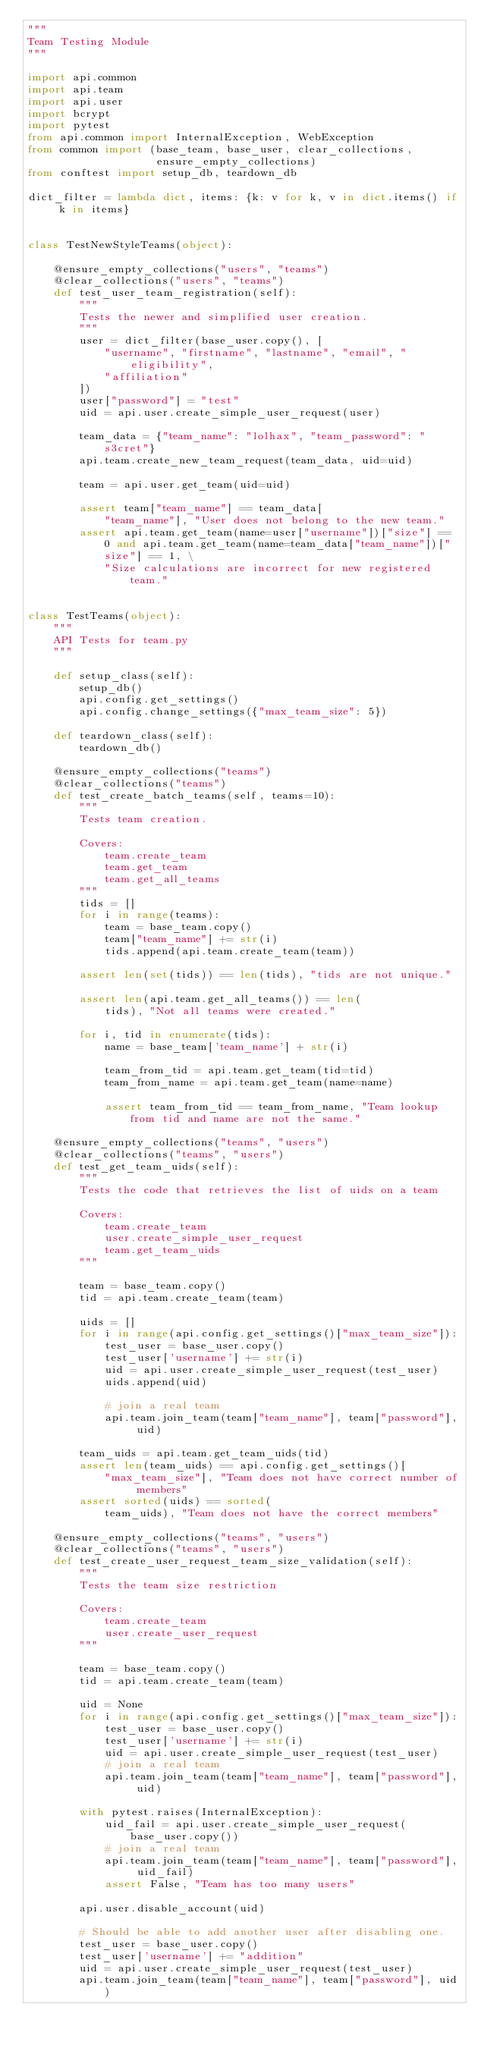<code> <loc_0><loc_0><loc_500><loc_500><_Python_>"""
Team Testing Module
"""

import api.common
import api.team
import api.user
import bcrypt
import pytest
from api.common import InternalException, WebException
from common import (base_team, base_user, clear_collections,
                    ensure_empty_collections)
from conftest import setup_db, teardown_db

dict_filter = lambda dict, items: {k: v for k, v in dict.items() if k in items}


class TestNewStyleTeams(object):

    @ensure_empty_collections("users", "teams")
    @clear_collections("users", "teams")
    def test_user_team_registration(self):
        """
        Tests the newer and simplified user creation.
        """
        user = dict_filter(base_user.copy(), [
            "username", "firstname", "lastname", "email", "eligibility",
            "affiliation"
        ])
        user["password"] = "test"
        uid = api.user.create_simple_user_request(user)

        team_data = {"team_name": "lolhax", "team_password": "s3cret"}
        api.team.create_new_team_request(team_data, uid=uid)

        team = api.user.get_team(uid=uid)

        assert team["team_name"] == team_data[
            "team_name"], "User does not belong to the new team."
        assert api.team.get_team(name=user["username"])["size"] == 0 and api.team.get_team(name=team_data["team_name"])["size"] == 1, \
            "Size calculations are incorrect for new registered team."


class TestTeams(object):
    """
    API Tests for team.py
    """

    def setup_class(self):
        setup_db()
        api.config.get_settings()
        api.config.change_settings({"max_team_size": 5})

    def teardown_class(self):
        teardown_db()

    @ensure_empty_collections("teams")
    @clear_collections("teams")
    def test_create_batch_teams(self, teams=10):
        """
        Tests team creation.

        Covers:
            team.create_team
            team.get_team
            team.get_all_teams
        """
        tids = []
        for i in range(teams):
            team = base_team.copy()
            team["team_name"] += str(i)
            tids.append(api.team.create_team(team))

        assert len(set(tids)) == len(tids), "tids are not unique."

        assert len(api.team.get_all_teams()) == len(
            tids), "Not all teams were created."

        for i, tid in enumerate(tids):
            name = base_team['team_name'] + str(i)

            team_from_tid = api.team.get_team(tid=tid)
            team_from_name = api.team.get_team(name=name)

            assert team_from_tid == team_from_name, "Team lookup from tid and name are not the same."

    @ensure_empty_collections("teams", "users")
    @clear_collections("teams", "users")
    def test_get_team_uids(self):
        """
        Tests the code that retrieves the list of uids on a team

        Covers:
            team.create_team
            user.create_simple_user_request
            team.get_team_uids
        """

        team = base_team.copy()
        tid = api.team.create_team(team)

        uids = []
        for i in range(api.config.get_settings()["max_team_size"]):
            test_user = base_user.copy()
            test_user['username'] += str(i)
            uid = api.user.create_simple_user_request(test_user)
            uids.append(uid)

            # join a real team
            api.team.join_team(team["team_name"], team["password"], uid)

        team_uids = api.team.get_team_uids(tid)
        assert len(team_uids) == api.config.get_settings()[
            "max_team_size"], "Team does not have correct number of members"
        assert sorted(uids) == sorted(
            team_uids), "Team does not have the correct members"

    @ensure_empty_collections("teams", "users")
    @clear_collections("teams", "users")
    def test_create_user_request_team_size_validation(self):
        """
        Tests the team size restriction

        Covers:
            team.create_team
            user.create_user_request
        """

        team = base_team.copy()
        tid = api.team.create_team(team)

        uid = None
        for i in range(api.config.get_settings()["max_team_size"]):
            test_user = base_user.copy()
            test_user['username'] += str(i)
            uid = api.user.create_simple_user_request(test_user)
            # join a real team
            api.team.join_team(team["team_name"], team["password"], uid)

        with pytest.raises(InternalException):
            uid_fail = api.user.create_simple_user_request(base_user.copy())
            # join a real team
            api.team.join_team(team["team_name"], team["password"], uid_fail)
            assert False, "Team has too many users"

        api.user.disable_account(uid)

        # Should be able to add another user after disabling one.
        test_user = base_user.copy()
        test_user['username'] += "addition"
        uid = api.user.create_simple_user_request(test_user)
        api.team.join_team(team["team_name"], team["password"], uid)
</code> 